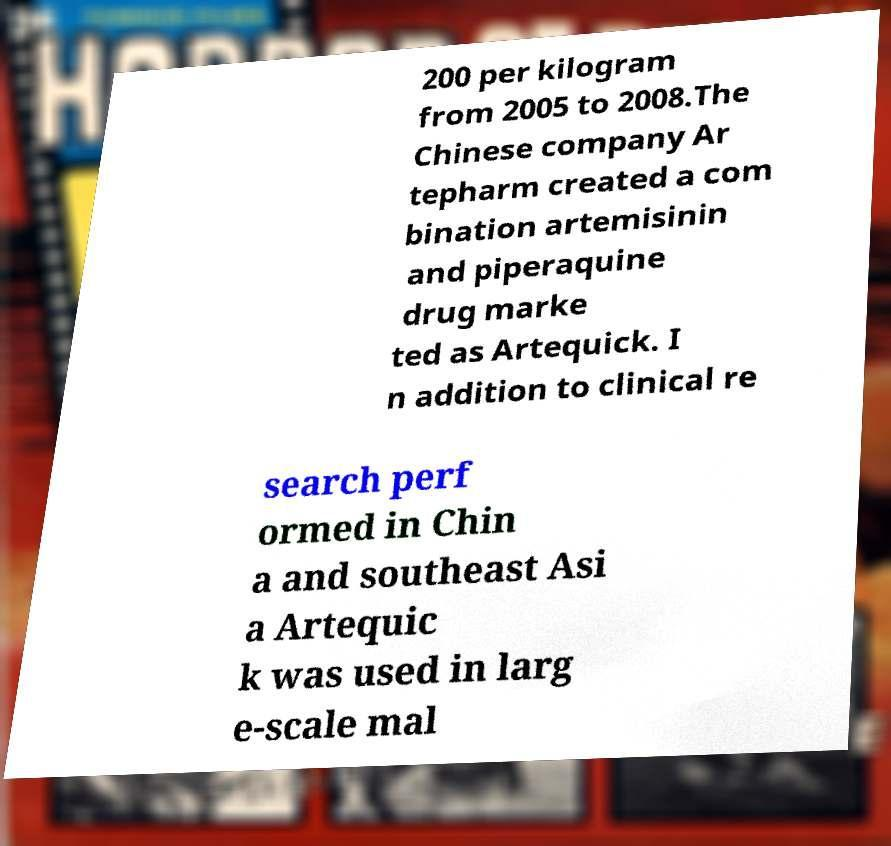There's text embedded in this image that I need extracted. Can you transcribe it verbatim? 200 per kilogram from 2005 to 2008.The Chinese company Ar tepharm created a com bination artemisinin and piperaquine drug marke ted as Artequick. I n addition to clinical re search perf ormed in Chin a and southeast Asi a Artequic k was used in larg e-scale mal 